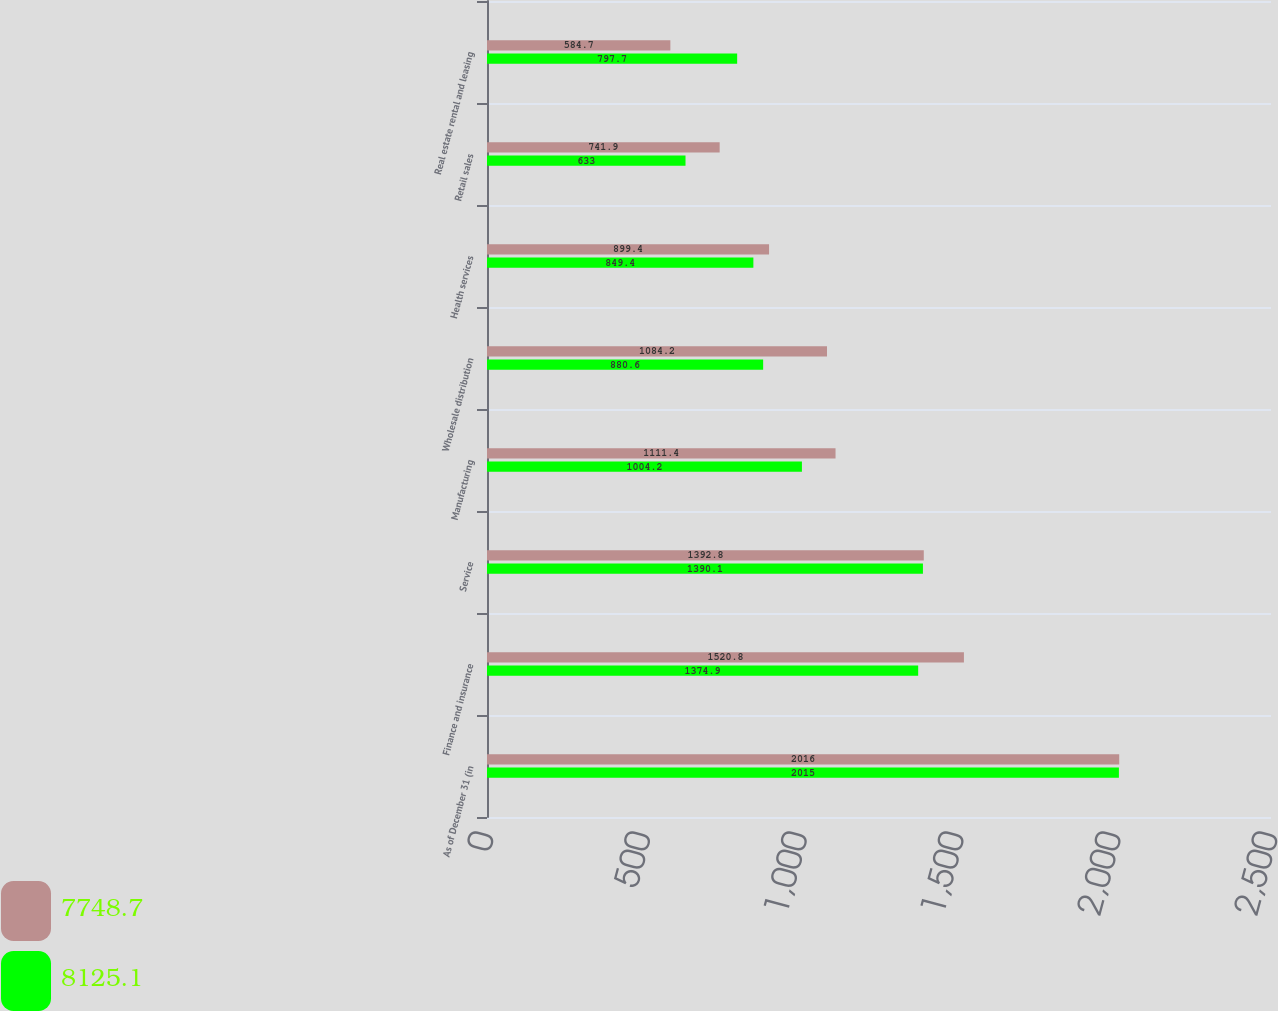<chart> <loc_0><loc_0><loc_500><loc_500><stacked_bar_chart><ecel><fcel>As of December 31 (in<fcel>Finance and insurance<fcel>Service<fcel>Manufacturing<fcel>Wholesale distribution<fcel>Health services<fcel>Retail sales<fcel>Real estate rental and leasing<nl><fcel>7748.7<fcel>2016<fcel>1520.8<fcel>1392.8<fcel>1111.4<fcel>1084.2<fcel>899.4<fcel>741.9<fcel>584.7<nl><fcel>8125.1<fcel>2015<fcel>1374.9<fcel>1390.1<fcel>1004.2<fcel>880.6<fcel>849.4<fcel>633<fcel>797.7<nl></chart> 